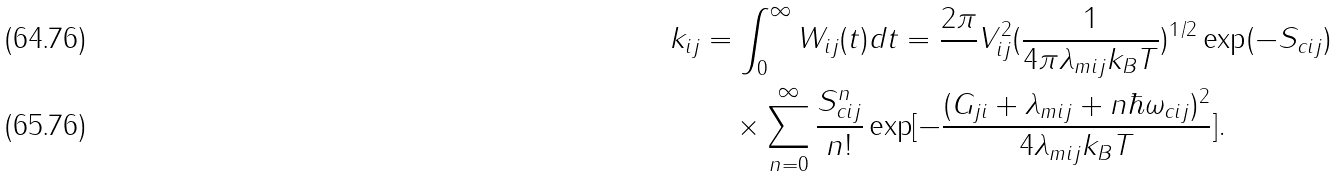<formula> <loc_0><loc_0><loc_500><loc_500>k _ { i j } & = \int _ { 0 } ^ { \infty } W _ { i j } ( t ) d t = \frac { 2 \pi } { } V _ { i j } ^ { 2 } ( \frac { 1 } { 4 \pi \lambda _ { m i j } k _ { B } T } ) ^ { 1 / 2 } \exp ( - S _ { c i j } ) \\ & \quad \times \sum ^ { \infty } _ { n = 0 } \frac { S _ { c i j } ^ { n } } { n ! } \exp [ - \frac { ( G _ { j i } + \lambda _ { m i j } + n \hbar { \omega } _ { c i j } ) ^ { 2 } } { 4 \lambda _ { m i j } k _ { B } T } ] .</formula> 